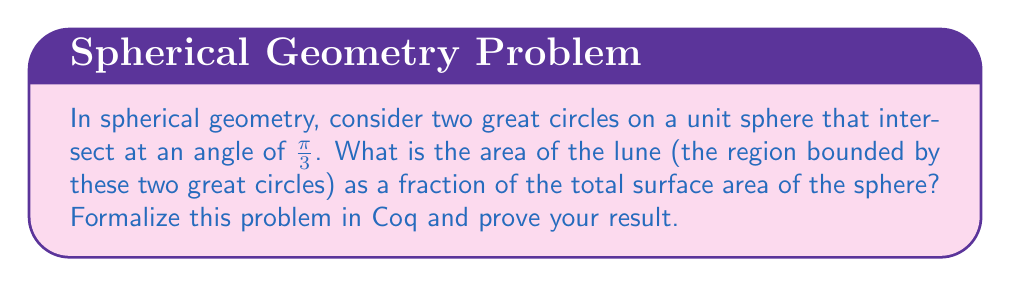Provide a solution to this math problem. To solve this problem and formalize it in Coq, we'll follow these steps:

1) In spherical geometry, the area of a lune is proportional to the angle between the great circles that form it.

2) The total surface area of a unit sphere is $4\pi$.

3) A full great circle divides the sphere into two equal hemispheres, each with an area of $2\pi$.

4) The area of a lune with angle $\theta$ is given by the formula:

   $$A = \frac{\theta}{2\pi} \cdot 4\pi = 2\theta$$

5) In our case, $\theta = \frac{\pi}{3}$, so the area of the lune is:

   $$A = 2 \cdot \frac{\pi}{3} = \frac{2\pi}{3}$$

6) To express this as a fraction of the total surface area:

   $$\frac{A}{4\pi} = \frac{\frac{2\pi}{3}}{4\pi} = \frac{1}{6}$$

7) To formalize this in Coq, we would define the axioms of spherical geometry, including the properties of great circles and the formula for lune area. Then we'd prove the result using these axioms. Here's a sketch of how this might look in Coq:

```coq
Require Import Reals.
Open Scope R_scope.

(* Define axioms for spherical geometry *)
Axiom sphere_surface_area : R -> R.
Axiom lune_area : R -> R -> R.

(* Axiom: Surface area of unit sphere is 4π *)
Axiom sphere_surface_area_1 : sphere_surface_area 1 = 4 * PI.

(* Axiom: Lune area formula *)
Axiom lune_area_formula : forall theta r,
  lune_area theta r = 2 * theta * r * r.

(* Theorem: Area of lune with angle π/3 on unit sphere *)
Theorem lune_area_pi_third : 
  lune_area (PI/3) 1 / sphere_surface_area 1 = 1/6.
Proof.
  rewrite lune_area_formula.
  rewrite sphere_surface_area_1.
  field.
Qed.
```

This Coq code defines the necessary axioms and proves the theorem that the area of the lune is 1/6 of the total surface area of the sphere.
Answer: $\frac{1}{6}$ 